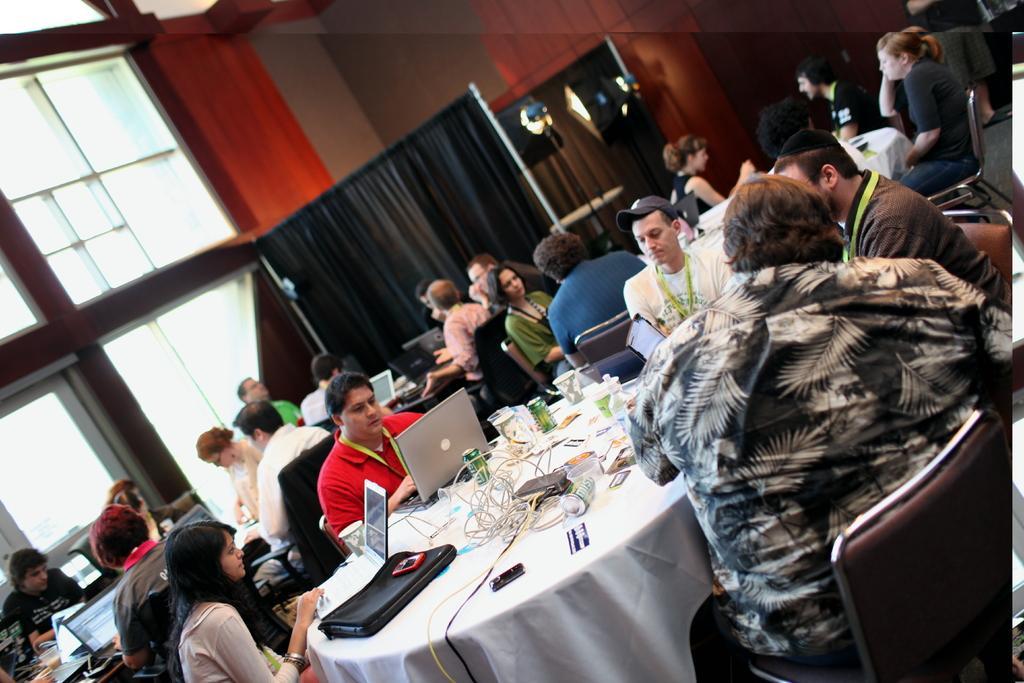Could you give a brief overview of what you see in this image? In this picture we can see a group of people sitting on chairs and in front of them we can see tables and on these tables we can see laptops, cables, tins, white clothes, bag, bottle, glass, device and in the background we can see the lights, curtains, walls, windows and some objects. 